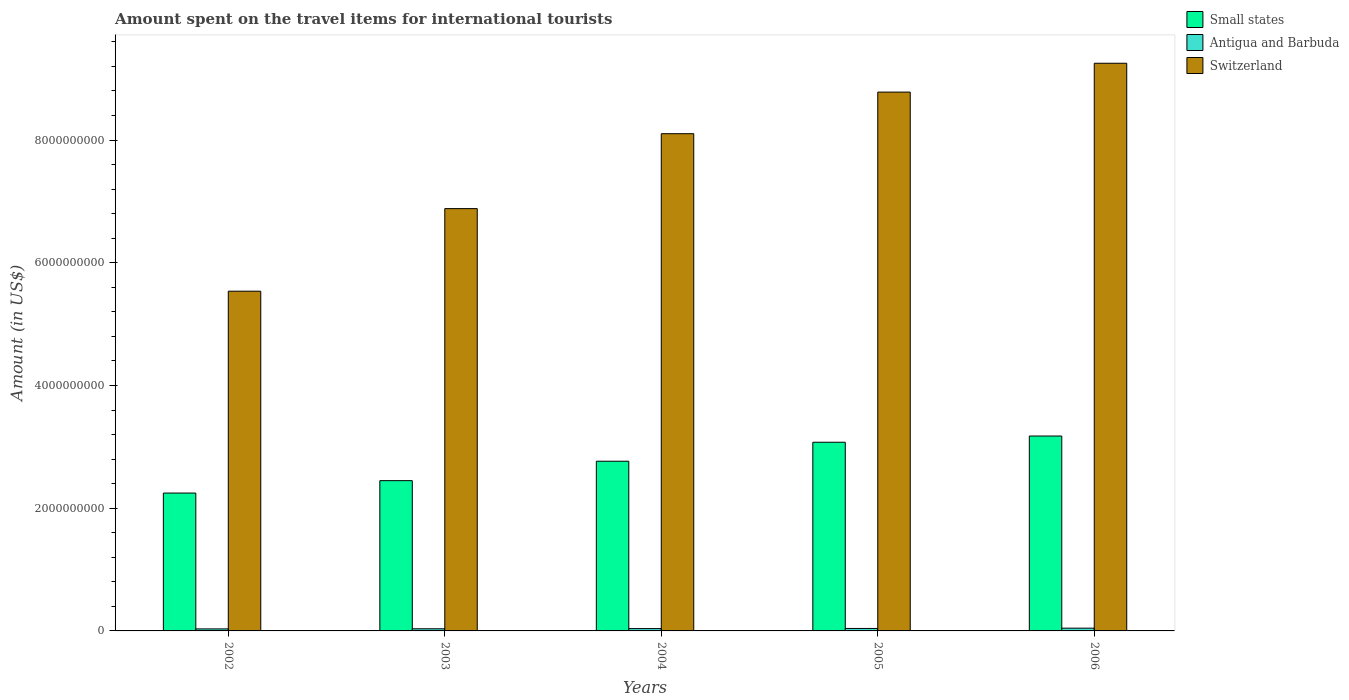Are the number of bars per tick equal to the number of legend labels?
Your answer should be compact. Yes. How many bars are there on the 2nd tick from the left?
Your answer should be compact. 3. What is the amount spent on the travel items for international tourists in Switzerland in 2005?
Give a very brief answer. 8.78e+09. Across all years, what is the maximum amount spent on the travel items for international tourists in Small states?
Ensure brevity in your answer.  3.18e+09. Across all years, what is the minimum amount spent on the travel items for international tourists in Switzerland?
Make the answer very short. 5.54e+09. What is the total amount spent on the travel items for international tourists in Small states in the graph?
Your answer should be compact. 1.37e+1. What is the difference between the amount spent on the travel items for international tourists in Switzerland in 2002 and that in 2004?
Your response must be concise. -2.57e+09. What is the difference between the amount spent on the travel items for international tourists in Antigua and Barbuda in 2003 and the amount spent on the travel items for international tourists in Small states in 2006?
Make the answer very short. -3.14e+09. What is the average amount spent on the travel items for international tourists in Small states per year?
Provide a succinct answer. 2.74e+09. In the year 2005, what is the difference between the amount spent on the travel items for international tourists in Small states and amount spent on the travel items for international tourists in Switzerland?
Ensure brevity in your answer.  -5.71e+09. What is the ratio of the amount spent on the travel items for international tourists in Small states in 2005 to that in 2006?
Provide a short and direct response. 0.97. What is the difference between the highest and the lowest amount spent on the travel items for international tourists in Antigua and Barbuda?
Your response must be concise. 1.20e+07. In how many years, is the amount spent on the travel items for international tourists in Antigua and Barbuda greater than the average amount spent on the travel items for international tourists in Antigua and Barbuda taken over all years?
Offer a very short reply. 2. Is the sum of the amount spent on the travel items for international tourists in Switzerland in 2005 and 2006 greater than the maximum amount spent on the travel items for international tourists in Small states across all years?
Your response must be concise. Yes. What does the 2nd bar from the left in 2004 represents?
Offer a terse response. Antigua and Barbuda. What does the 3rd bar from the right in 2003 represents?
Provide a succinct answer. Small states. Does the graph contain grids?
Provide a succinct answer. No. Where does the legend appear in the graph?
Offer a terse response. Top right. How are the legend labels stacked?
Provide a succinct answer. Vertical. What is the title of the graph?
Offer a terse response. Amount spent on the travel items for international tourists. What is the label or title of the Y-axis?
Offer a very short reply. Amount (in US$). What is the Amount (in US$) of Small states in 2002?
Ensure brevity in your answer.  2.25e+09. What is the Amount (in US$) in Antigua and Barbuda in 2002?
Make the answer very short. 3.30e+07. What is the Amount (in US$) in Switzerland in 2002?
Your response must be concise. 5.54e+09. What is the Amount (in US$) in Small states in 2003?
Keep it short and to the point. 2.45e+09. What is the Amount (in US$) of Antigua and Barbuda in 2003?
Your response must be concise. 3.50e+07. What is the Amount (in US$) of Switzerland in 2003?
Provide a succinct answer. 6.88e+09. What is the Amount (in US$) in Small states in 2004?
Give a very brief answer. 2.77e+09. What is the Amount (in US$) in Antigua and Barbuda in 2004?
Offer a very short reply. 3.80e+07. What is the Amount (in US$) of Switzerland in 2004?
Ensure brevity in your answer.  8.10e+09. What is the Amount (in US$) of Small states in 2005?
Offer a terse response. 3.08e+09. What is the Amount (in US$) in Antigua and Barbuda in 2005?
Your response must be concise. 4.00e+07. What is the Amount (in US$) in Switzerland in 2005?
Offer a terse response. 8.78e+09. What is the Amount (in US$) of Small states in 2006?
Your answer should be compact. 3.18e+09. What is the Amount (in US$) in Antigua and Barbuda in 2006?
Offer a terse response. 4.50e+07. What is the Amount (in US$) of Switzerland in 2006?
Provide a succinct answer. 9.25e+09. Across all years, what is the maximum Amount (in US$) in Small states?
Your answer should be very brief. 3.18e+09. Across all years, what is the maximum Amount (in US$) in Antigua and Barbuda?
Make the answer very short. 4.50e+07. Across all years, what is the maximum Amount (in US$) of Switzerland?
Provide a succinct answer. 9.25e+09. Across all years, what is the minimum Amount (in US$) in Small states?
Your answer should be very brief. 2.25e+09. Across all years, what is the minimum Amount (in US$) of Antigua and Barbuda?
Provide a short and direct response. 3.30e+07. Across all years, what is the minimum Amount (in US$) of Switzerland?
Your answer should be compact. 5.54e+09. What is the total Amount (in US$) of Small states in the graph?
Offer a very short reply. 1.37e+1. What is the total Amount (in US$) of Antigua and Barbuda in the graph?
Give a very brief answer. 1.91e+08. What is the total Amount (in US$) of Switzerland in the graph?
Make the answer very short. 3.86e+1. What is the difference between the Amount (in US$) in Small states in 2002 and that in 2003?
Your answer should be very brief. -2.02e+08. What is the difference between the Amount (in US$) in Switzerland in 2002 and that in 2003?
Keep it short and to the point. -1.35e+09. What is the difference between the Amount (in US$) in Small states in 2002 and that in 2004?
Make the answer very short. -5.19e+08. What is the difference between the Amount (in US$) in Antigua and Barbuda in 2002 and that in 2004?
Your response must be concise. -5.00e+06. What is the difference between the Amount (in US$) of Switzerland in 2002 and that in 2004?
Your response must be concise. -2.57e+09. What is the difference between the Amount (in US$) of Small states in 2002 and that in 2005?
Provide a succinct answer. -8.28e+08. What is the difference between the Amount (in US$) of Antigua and Barbuda in 2002 and that in 2005?
Offer a terse response. -7.00e+06. What is the difference between the Amount (in US$) in Switzerland in 2002 and that in 2005?
Keep it short and to the point. -3.24e+09. What is the difference between the Amount (in US$) in Small states in 2002 and that in 2006?
Keep it short and to the point. -9.29e+08. What is the difference between the Amount (in US$) of Antigua and Barbuda in 2002 and that in 2006?
Provide a short and direct response. -1.20e+07. What is the difference between the Amount (in US$) in Switzerland in 2002 and that in 2006?
Your answer should be very brief. -3.72e+09. What is the difference between the Amount (in US$) of Small states in 2003 and that in 2004?
Your answer should be very brief. -3.16e+08. What is the difference between the Amount (in US$) in Switzerland in 2003 and that in 2004?
Keep it short and to the point. -1.22e+09. What is the difference between the Amount (in US$) of Small states in 2003 and that in 2005?
Your answer should be compact. -6.26e+08. What is the difference between the Amount (in US$) in Antigua and Barbuda in 2003 and that in 2005?
Offer a very short reply. -5.00e+06. What is the difference between the Amount (in US$) of Switzerland in 2003 and that in 2005?
Keep it short and to the point. -1.90e+09. What is the difference between the Amount (in US$) of Small states in 2003 and that in 2006?
Provide a short and direct response. -7.27e+08. What is the difference between the Amount (in US$) in Antigua and Barbuda in 2003 and that in 2006?
Provide a succinct answer. -1.00e+07. What is the difference between the Amount (in US$) in Switzerland in 2003 and that in 2006?
Your answer should be very brief. -2.37e+09. What is the difference between the Amount (in US$) in Small states in 2004 and that in 2005?
Provide a succinct answer. -3.09e+08. What is the difference between the Amount (in US$) in Antigua and Barbuda in 2004 and that in 2005?
Offer a very short reply. -2.00e+06. What is the difference between the Amount (in US$) in Switzerland in 2004 and that in 2005?
Offer a terse response. -6.78e+08. What is the difference between the Amount (in US$) in Small states in 2004 and that in 2006?
Offer a very short reply. -4.11e+08. What is the difference between the Amount (in US$) in Antigua and Barbuda in 2004 and that in 2006?
Offer a very short reply. -7.00e+06. What is the difference between the Amount (in US$) of Switzerland in 2004 and that in 2006?
Your answer should be compact. -1.15e+09. What is the difference between the Amount (in US$) in Small states in 2005 and that in 2006?
Your answer should be very brief. -1.01e+08. What is the difference between the Amount (in US$) of Antigua and Barbuda in 2005 and that in 2006?
Your answer should be very brief. -5.00e+06. What is the difference between the Amount (in US$) in Switzerland in 2005 and that in 2006?
Keep it short and to the point. -4.70e+08. What is the difference between the Amount (in US$) of Small states in 2002 and the Amount (in US$) of Antigua and Barbuda in 2003?
Provide a succinct answer. 2.21e+09. What is the difference between the Amount (in US$) in Small states in 2002 and the Amount (in US$) in Switzerland in 2003?
Make the answer very short. -4.64e+09. What is the difference between the Amount (in US$) of Antigua and Barbuda in 2002 and the Amount (in US$) of Switzerland in 2003?
Give a very brief answer. -6.85e+09. What is the difference between the Amount (in US$) in Small states in 2002 and the Amount (in US$) in Antigua and Barbuda in 2004?
Provide a short and direct response. 2.21e+09. What is the difference between the Amount (in US$) in Small states in 2002 and the Amount (in US$) in Switzerland in 2004?
Your answer should be very brief. -5.86e+09. What is the difference between the Amount (in US$) of Antigua and Barbuda in 2002 and the Amount (in US$) of Switzerland in 2004?
Offer a very short reply. -8.07e+09. What is the difference between the Amount (in US$) in Small states in 2002 and the Amount (in US$) in Antigua and Barbuda in 2005?
Your response must be concise. 2.21e+09. What is the difference between the Amount (in US$) of Small states in 2002 and the Amount (in US$) of Switzerland in 2005?
Ensure brevity in your answer.  -6.53e+09. What is the difference between the Amount (in US$) of Antigua and Barbuda in 2002 and the Amount (in US$) of Switzerland in 2005?
Offer a terse response. -8.75e+09. What is the difference between the Amount (in US$) in Small states in 2002 and the Amount (in US$) in Antigua and Barbuda in 2006?
Keep it short and to the point. 2.20e+09. What is the difference between the Amount (in US$) in Small states in 2002 and the Amount (in US$) in Switzerland in 2006?
Provide a succinct answer. -7.00e+09. What is the difference between the Amount (in US$) in Antigua and Barbuda in 2002 and the Amount (in US$) in Switzerland in 2006?
Your response must be concise. -9.22e+09. What is the difference between the Amount (in US$) of Small states in 2003 and the Amount (in US$) of Antigua and Barbuda in 2004?
Provide a short and direct response. 2.41e+09. What is the difference between the Amount (in US$) in Small states in 2003 and the Amount (in US$) in Switzerland in 2004?
Ensure brevity in your answer.  -5.65e+09. What is the difference between the Amount (in US$) in Antigua and Barbuda in 2003 and the Amount (in US$) in Switzerland in 2004?
Your answer should be very brief. -8.07e+09. What is the difference between the Amount (in US$) in Small states in 2003 and the Amount (in US$) in Antigua and Barbuda in 2005?
Give a very brief answer. 2.41e+09. What is the difference between the Amount (in US$) in Small states in 2003 and the Amount (in US$) in Switzerland in 2005?
Your answer should be compact. -6.33e+09. What is the difference between the Amount (in US$) of Antigua and Barbuda in 2003 and the Amount (in US$) of Switzerland in 2005?
Your response must be concise. -8.75e+09. What is the difference between the Amount (in US$) in Small states in 2003 and the Amount (in US$) in Antigua and Barbuda in 2006?
Your answer should be compact. 2.40e+09. What is the difference between the Amount (in US$) of Small states in 2003 and the Amount (in US$) of Switzerland in 2006?
Keep it short and to the point. -6.80e+09. What is the difference between the Amount (in US$) in Antigua and Barbuda in 2003 and the Amount (in US$) in Switzerland in 2006?
Offer a very short reply. -9.22e+09. What is the difference between the Amount (in US$) of Small states in 2004 and the Amount (in US$) of Antigua and Barbuda in 2005?
Your answer should be compact. 2.73e+09. What is the difference between the Amount (in US$) of Small states in 2004 and the Amount (in US$) of Switzerland in 2005?
Keep it short and to the point. -6.02e+09. What is the difference between the Amount (in US$) in Antigua and Barbuda in 2004 and the Amount (in US$) in Switzerland in 2005?
Keep it short and to the point. -8.74e+09. What is the difference between the Amount (in US$) in Small states in 2004 and the Amount (in US$) in Antigua and Barbuda in 2006?
Your answer should be very brief. 2.72e+09. What is the difference between the Amount (in US$) in Small states in 2004 and the Amount (in US$) in Switzerland in 2006?
Offer a terse response. -6.49e+09. What is the difference between the Amount (in US$) of Antigua and Barbuda in 2004 and the Amount (in US$) of Switzerland in 2006?
Ensure brevity in your answer.  -9.21e+09. What is the difference between the Amount (in US$) of Small states in 2005 and the Amount (in US$) of Antigua and Barbuda in 2006?
Keep it short and to the point. 3.03e+09. What is the difference between the Amount (in US$) of Small states in 2005 and the Amount (in US$) of Switzerland in 2006?
Your answer should be compact. -6.18e+09. What is the difference between the Amount (in US$) in Antigua and Barbuda in 2005 and the Amount (in US$) in Switzerland in 2006?
Keep it short and to the point. -9.21e+09. What is the average Amount (in US$) in Small states per year?
Ensure brevity in your answer.  2.74e+09. What is the average Amount (in US$) in Antigua and Barbuda per year?
Ensure brevity in your answer.  3.82e+07. What is the average Amount (in US$) in Switzerland per year?
Make the answer very short. 7.71e+09. In the year 2002, what is the difference between the Amount (in US$) in Small states and Amount (in US$) in Antigua and Barbuda?
Provide a succinct answer. 2.21e+09. In the year 2002, what is the difference between the Amount (in US$) of Small states and Amount (in US$) of Switzerland?
Keep it short and to the point. -3.29e+09. In the year 2002, what is the difference between the Amount (in US$) of Antigua and Barbuda and Amount (in US$) of Switzerland?
Provide a succinct answer. -5.50e+09. In the year 2003, what is the difference between the Amount (in US$) in Small states and Amount (in US$) in Antigua and Barbuda?
Give a very brief answer. 2.41e+09. In the year 2003, what is the difference between the Amount (in US$) of Small states and Amount (in US$) of Switzerland?
Your response must be concise. -4.43e+09. In the year 2003, what is the difference between the Amount (in US$) of Antigua and Barbuda and Amount (in US$) of Switzerland?
Provide a succinct answer. -6.85e+09. In the year 2004, what is the difference between the Amount (in US$) in Small states and Amount (in US$) in Antigua and Barbuda?
Ensure brevity in your answer.  2.73e+09. In the year 2004, what is the difference between the Amount (in US$) in Small states and Amount (in US$) in Switzerland?
Provide a succinct answer. -5.34e+09. In the year 2004, what is the difference between the Amount (in US$) in Antigua and Barbuda and Amount (in US$) in Switzerland?
Your answer should be compact. -8.07e+09. In the year 2005, what is the difference between the Amount (in US$) of Small states and Amount (in US$) of Antigua and Barbuda?
Give a very brief answer. 3.04e+09. In the year 2005, what is the difference between the Amount (in US$) of Small states and Amount (in US$) of Switzerland?
Offer a very short reply. -5.71e+09. In the year 2005, what is the difference between the Amount (in US$) in Antigua and Barbuda and Amount (in US$) in Switzerland?
Offer a terse response. -8.74e+09. In the year 2006, what is the difference between the Amount (in US$) in Small states and Amount (in US$) in Antigua and Barbuda?
Your answer should be compact. 3.13e+09. In the year 2006, what is the difference between the Amount (in US$) in Small states and Amount (in US$) in Switzerland?
Your answer should be very brief. -6.08e+09. In the year 2006, what is the difference between the Amount (in US$) in Antigua and Barbuda and Amount (in US$) in Switzerland?
Make the answer very short. -9.21e+09. What is the ratio of the Amount (in US$) in Small states in 2002 to that in 2003?
Your answer should be compact. 0.92. What is the ratio of the Amount (in US$) of Antigua and Barbuda in 2002 to that in 2003?
Your answer should be very brief. 0.94. What is the ratio of the Amount (in US$) in Switzerland in 2002 to that in 2003?
Your answer should be very brief. 0.8. What is the ratio of the Amount (in US$) of Small states in 2002 to that in 2004?
Offer a terse response. 0.81. What is the ratio of the Amount (in US$) in Antigua and Barbuda in 2002 to that in 2004?
Ensure brevity in your answer.  0.87. What is the ratio of the Amount (in US$) of Switzerland in 2002 to that in 2004?
Offer a very short reply. 0.68. What is the ratio of the Amount (in US$) in Small states in 2002 to that in 2005?
Offer a very short reply. 0.73. What is the ratio of the Amount (in US$) of Antigua and Barbuda in 2002 to that in 2005?
Give a very brief answer. 0.82. What is the ratio of the Amount (in US$) of Switzerland in 2002 to that in 2005?
Your response must be concise. 0.63. What is the ratio of the Amount (in US$) in Small states in 2002 to that in 2006?
Give a very brief answer. 0.71. What is the ratio of the Amount (in US$) in Antigua and Barbuda in 2002 to that in 2006?
Give a very brief answer. 0.73. What is the ratio of the Amount (in US$) of Switzerland in 2002 to that in 2006?
Keep it short and to the point. 0.6. What is the ratio of the Amount (in US$) of Small states in 2003 to that in 2004?
Your response must be concise. 0.89. What is the ratio of the Amount (in US$) of Antigua and Barbuda in 2003 to that in 2004?
Give a very brief answer. 0.92. What is the ratio of the Amount (in US$) of Switzerland in 2003 to that in 2004?
Ensure brevity in your answer.  0.85. What is the ratio of the Amount (in US$) of Small states in 2003 to that in 2005?
Ensure brevity in your answer.  0.8. What is the ratio of the Amount (in US$) in Switzerland in 2003 to that in 2005?
Keep it short and to the point. 0.78. What is the ratio of the Amount (in US$) of Small states in 2003 to that in 2006?
Your response must be concise. 0.77. What is the ratio of the Amount (in US$) of Switzerland in 2003 to that in 2006?
Your answer should be compact. 0.74. What is the ratio of the Amount (in US$) of Small states in 2004 to that in 2005?
Your answer should be very brief. 0.9. What is the ratio of the Amount (in US$) of Switzerland in 2004 to that in 2005?
Offer a very short reply. 0.92. What is the ratio of the Amount (in US$) of Small states in 2004 to that in 2006?
Your response must be concise. 0.87. What is the ratio of the Amount (in US$) in Antigua and Barbuda in 2004 to that in 2006?
Offer a terse response. 0.84. What is the ratio of the Amount (in US$) of Switzerland in 2004 to that in 2006?
Offer a very short reply. 0.88. What is the ratio of the Amount (in US$) of Small states in 2005 to that in 2006?
Offer a very short reply. 0.97. What is the ratio of the Amount (in US$) in Antigua and Barbuda in 2005 to that in 2006?
Your answer should be compact. 0.89. What is the ratio of the Amount (in US$) of Switzerland in 2005 to that in 2006?
Keep it short and to the point. 0.95. What is the difference between the highest and the second highest Amount (in US$) of Small states?
Your response must be concise. 1.01e+08. What is the difference between the highest and the second highest Amount (in US$) in Switzerland?
Provide a succinct answer. 4.70e+08. What is the difference between the highest and the lowest Amount (in US$) in Small states?
Provide a short and direct response. 9.29e+08. What is the difference between the highest and the lowest Amount (in US$) of Switzerland?
Make the answer very short. 3.72e+09. 